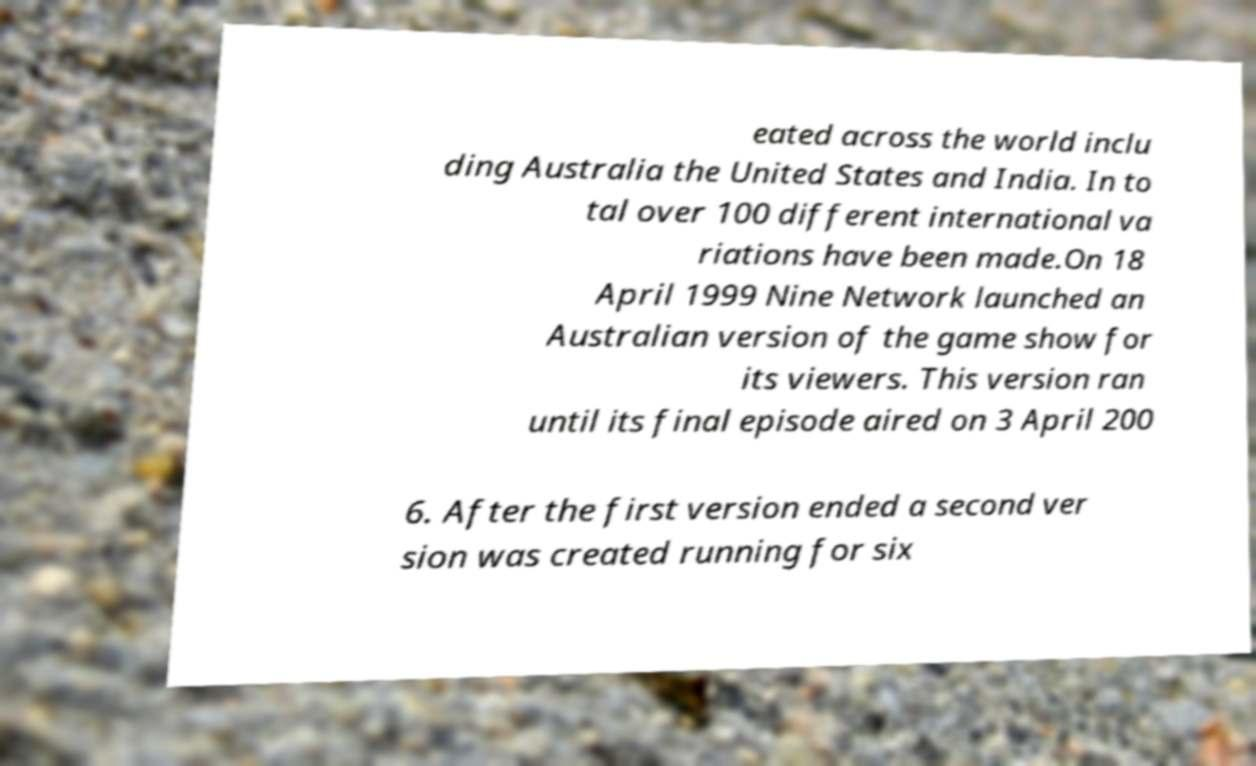For documentation purposes, I need the text within this image transcribed. Could you provide that? eated across the world inclu ding Australia the United States and India. In to tal over 100 different international va riations have been made.On 18 April 1999 Nine Network launched an Australian version of the game show for its viewers. This version ran until its final episode aired on 3 April 200 6. After the first version ended a second ver sion was created running for six 